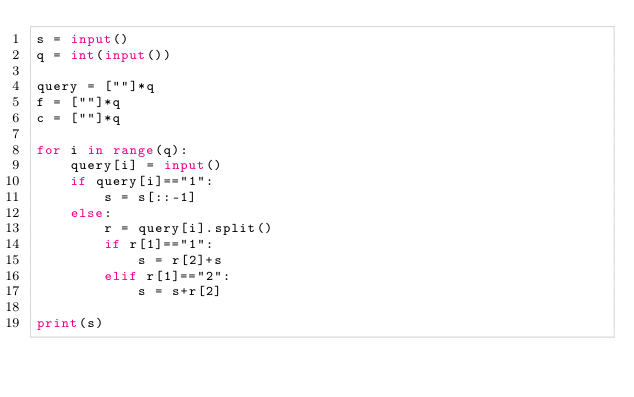<code> <loc_0><loc_0><loc_500><loc_500><_Python_>s = input()
q = int(input())

query = [""]*q
f = [""]*q
c = [""]*q

for i in range(q):
    query[i] = input()
    if query[i]=="1":
        s = s[::-1]
    else:
        r = query[i].split()
        if r[1]=="1":
            s = r[2]+s
        elif r[1]=="2":
            s = s+r[2]

print(s)</code> 